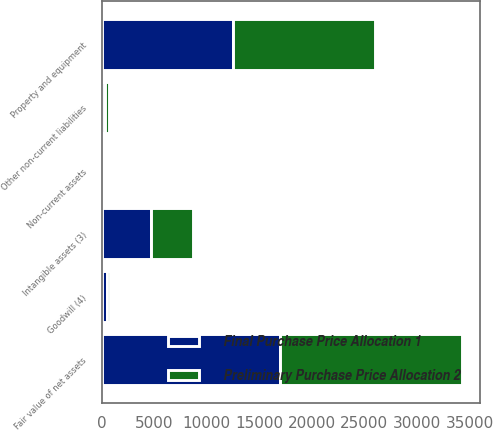Convert chart to OTSL. <chart><loc_0><loc_0><loc_500><loc_500><stacked_bar_chart><ecel><fcel>Non-current assets<fcel>Property and equipment<fcel>Intangible assets (3)<fcel>Other non-current liabilities<fcel>Fair value of net assets<fcel>Goodwill (4)<nl><fcel>Preliminary Purchase Price Allocation 2<fcel>110<fcel>13526<fcel>4008<fcel>341<fcel>17303<fcel>227<nl><fcel>Final Purchase Price Allocation 1<fcel>217<fcel>12456<fcel>4675<fcel>341<fcel>17007<fcel>523<nl></chart> 